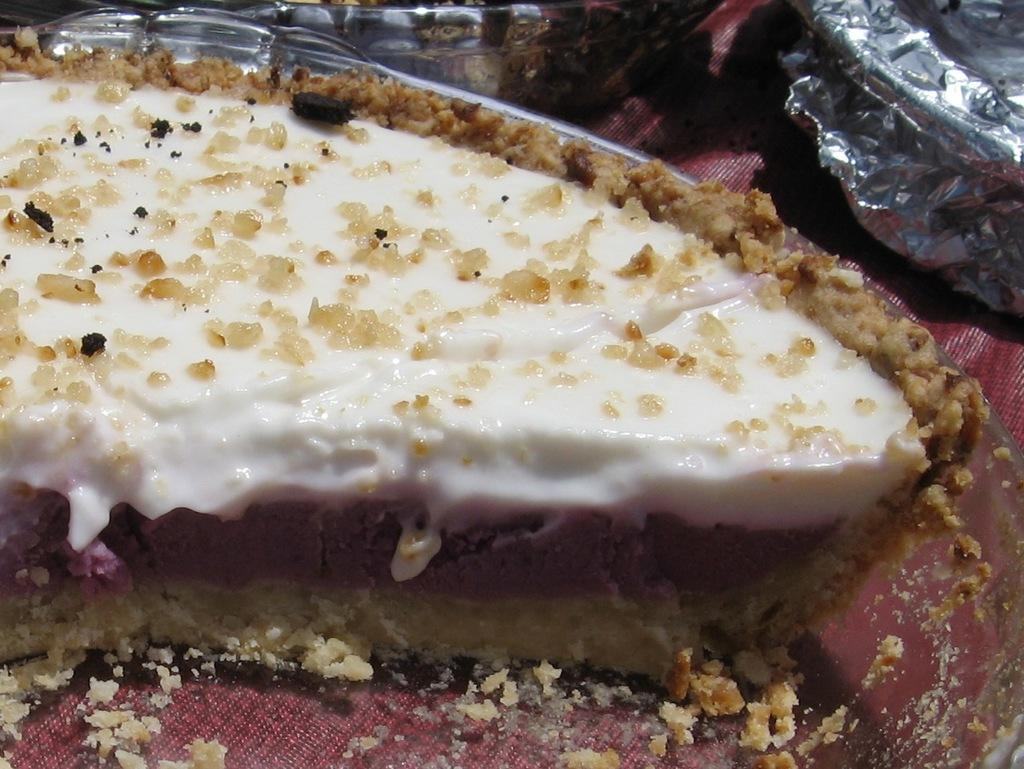What type of food can be seen in the image? There is food in the image, but the specific type is not mentioned. What is the food contained in? There is a bowl in the image that contains the food. Is there anything covering the bowl? Yes, there is a cover in the image that is placed over the bowl. What color is the surface the bowl is placed on? The surface is maroon in color. Can you see a cat playing with a marble on the maroon surface in the image? No, there is no cat or marble present in the image. What type of offer is being made in the image? There is no offer being made in the image; it only contains food, a bowl, a cover, and a maroon surface. 